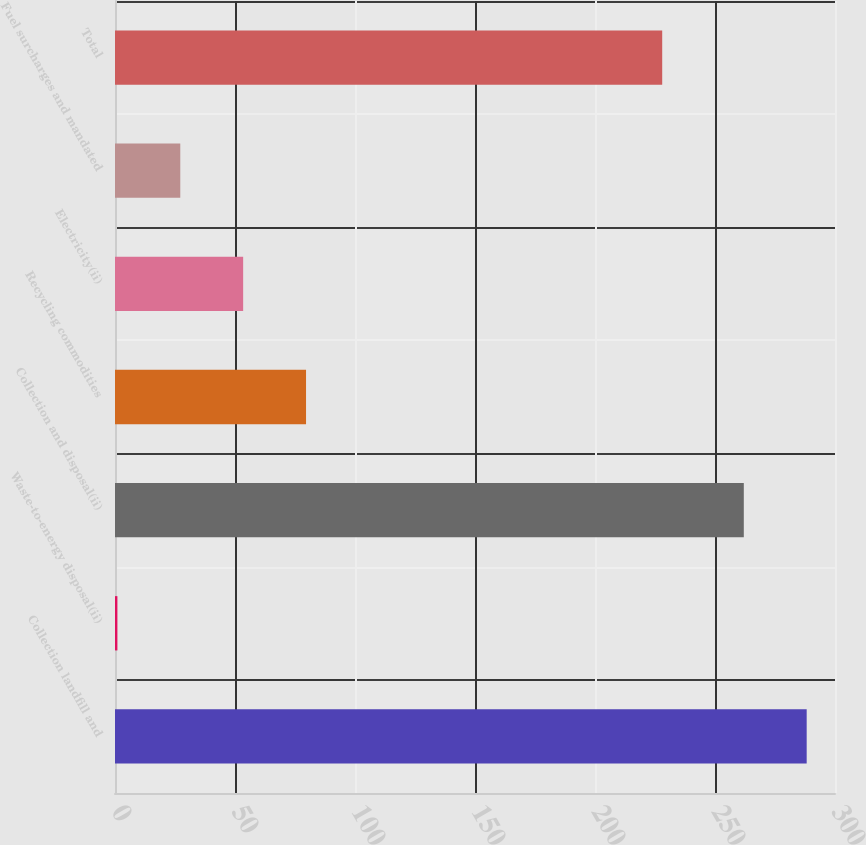Convert chart. <chart><loc_0><loc_0><loc_500><loc_500><bar_chart><fcel>Collection landfill and<fcel>Waste-to-energy disposal(ii)<fcel>Collection and disposal(ii)<fcel>Recycling commodities<fcel>Electricity(ii)<fcel>Fuel surcharges and mandated<fcel>Total<nl><fcel>288.2<fcel>1<fcel>262<fcel>79.6<fcel>53.4<fcel>27.2<fcel>228<nl></chart> 